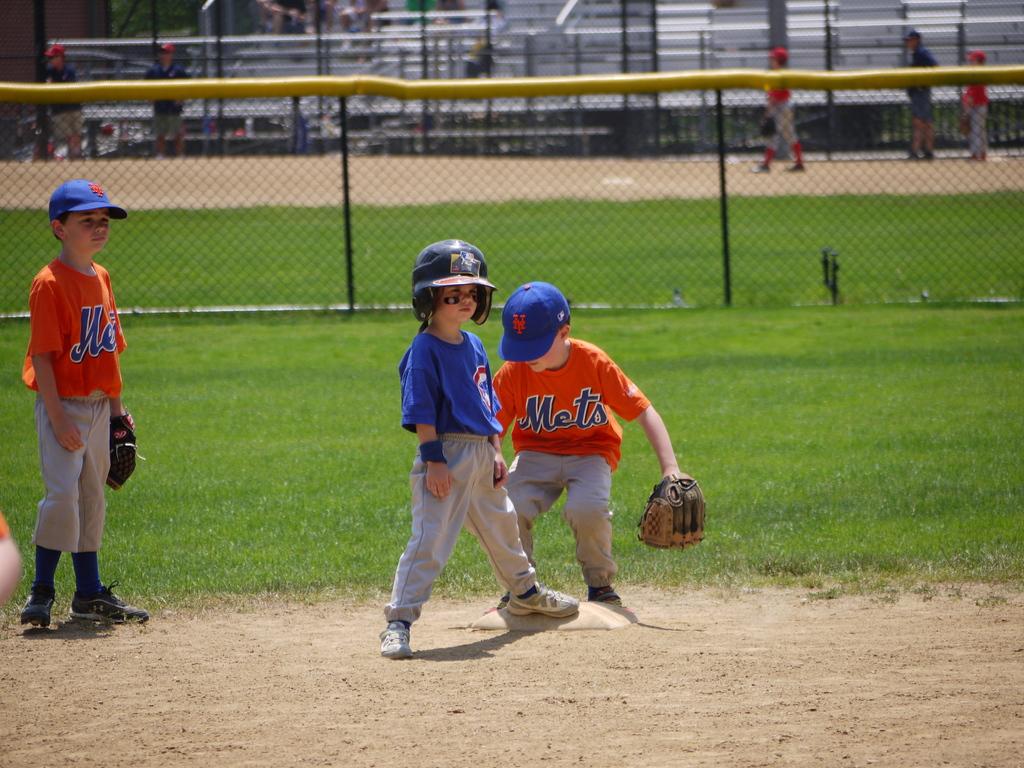What is the team name on the orange jersey?
Provide a short and direct response. Mets. 